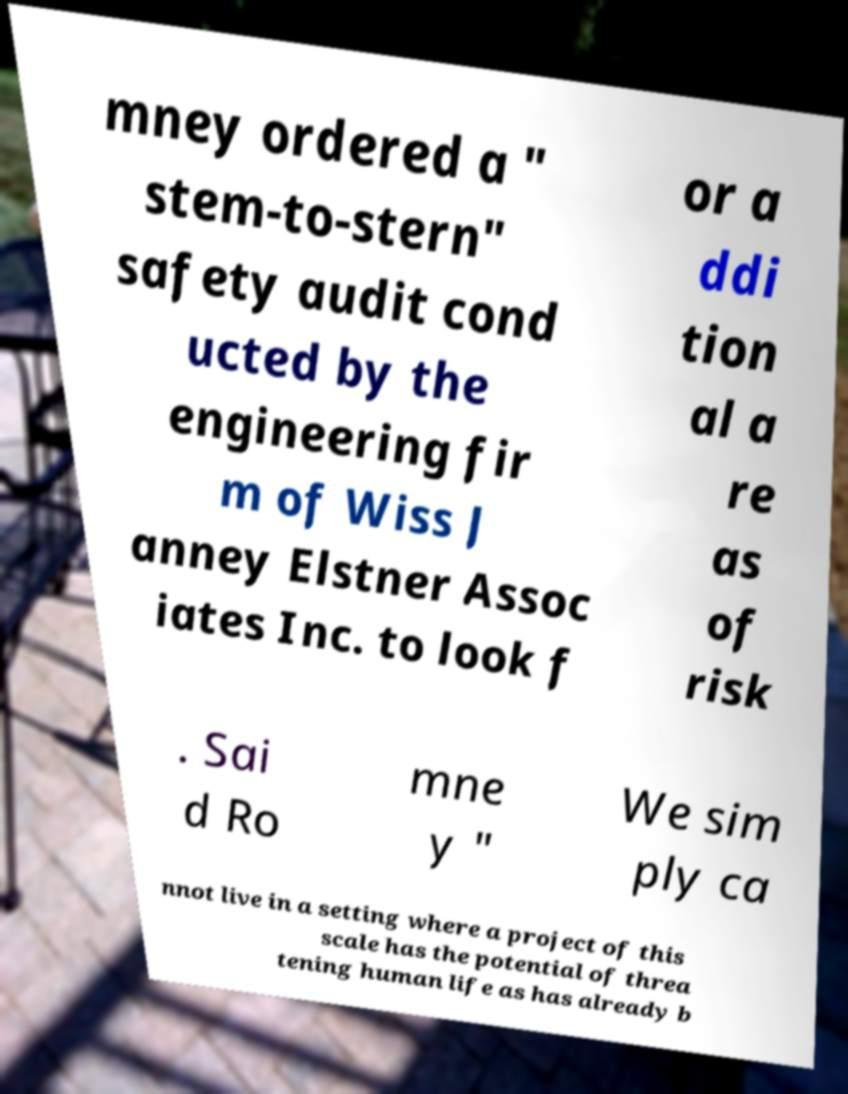There's text embedded in this image that I need extracted. Can you transcribe it verbatim? mney ordered a " stem-to-stern" safety audit cond ucted by the engineering fir m of Wiss J anney Elstner Assoc iates Inc. to look f or a ddi tion al a re as of risk . Sai d Ro mne y " We sim ply ca nnot live in a setting where a project of this scale has the potential of threa tening human life as has already b 